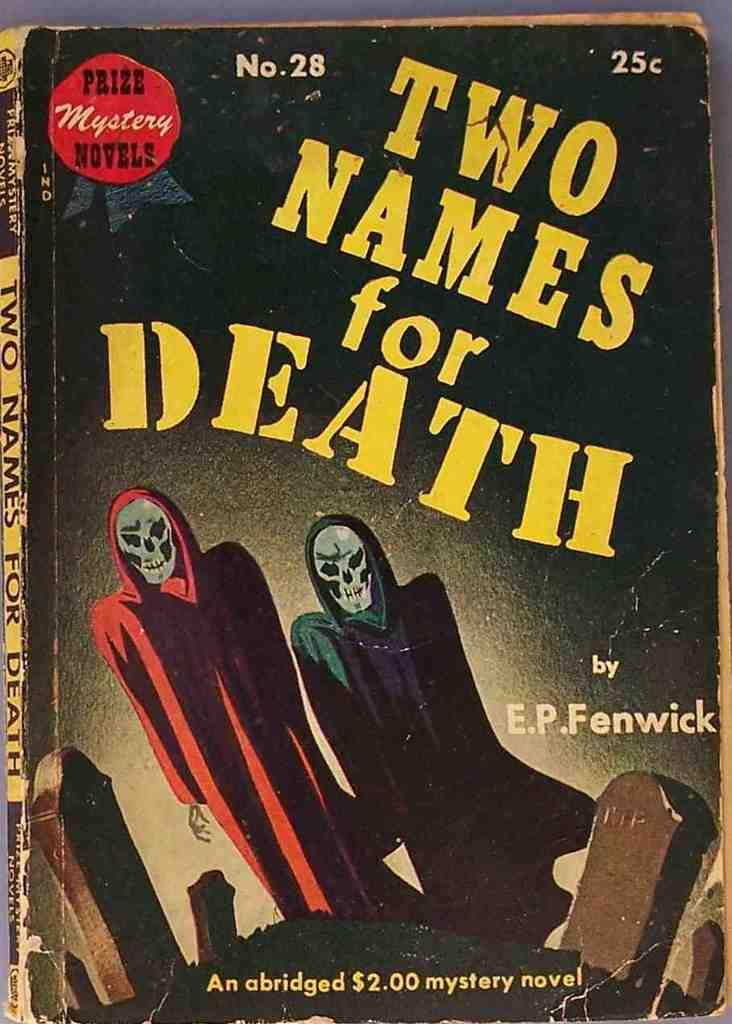<image>
Share a concise interpretation of the image provided. a book that has Two Names for Death on it 